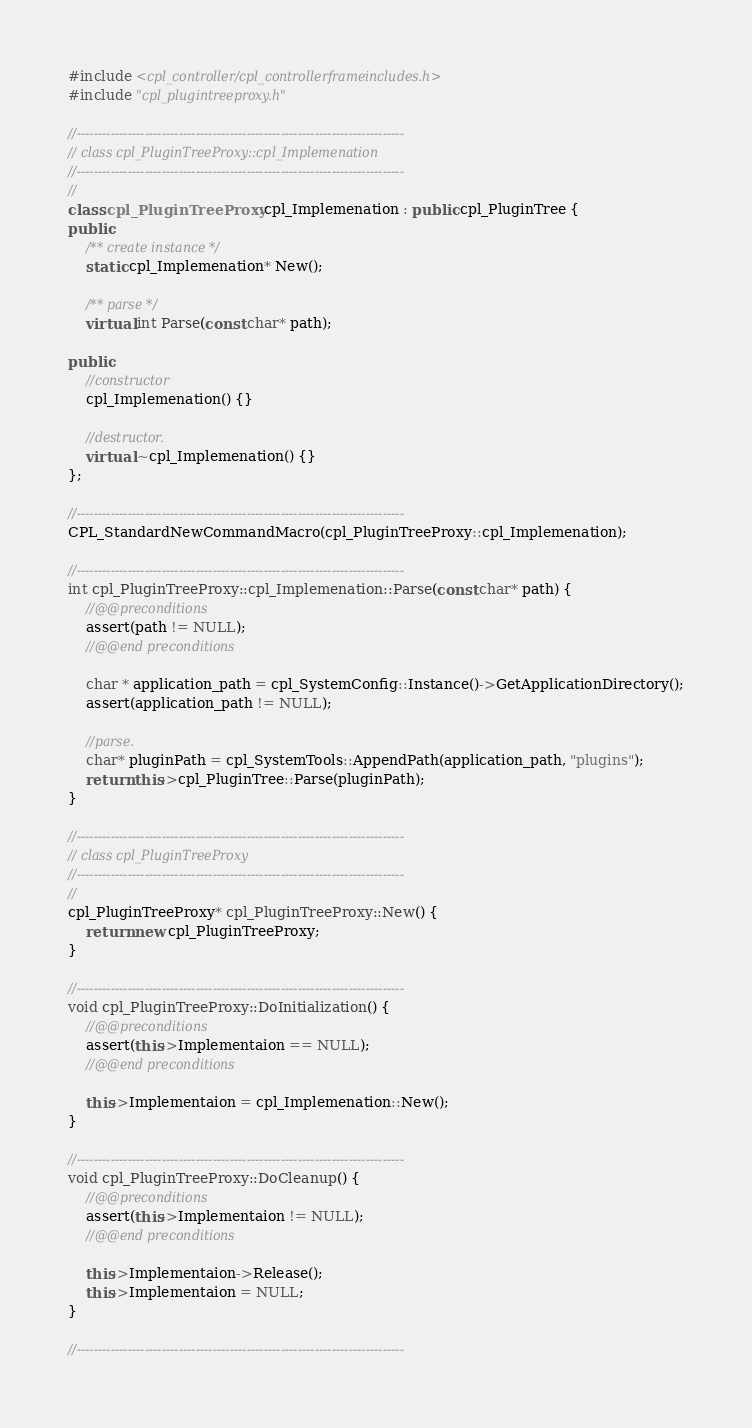<code> <loc_0><loc_0><loc_500><loc_500><_C++_>#include <cpl_controller/cpl_controllerframeincludes.h>
#include "cpl_plugintreeproxy.h"

//-----------------------------------------------------------------------------
// class cpl_PluginTreeProxy::cpl_Implemenation
//-----------------------------------------------------------------------------
//
class cpl_PluginTreeProxy::cpl_Implemenation : public cpl_PluginTree {   
public:
    /** create instance */
    static cpl_Implemenation* New();

    /** parse */
    virtual int Parse(const char* path);

public:
    //constructor
    cpl_Implemenation() {}

    //destructor.
    virtual ~cpl_Implemenation() {}
};

//-----------------------------------------------------------------------------
CPL_StandardNewCommandMacro(cpl_PluginTreeProxy::cpl_Implemenation);

//-----------------------------------------------------------------------------
int cpl_PluginTreeProxy::cpl_Implemenation::Parse(const char* path) {
    //@@preconditions
    assert(path != NULL);
    //@@end preconditions
    
    char * application_path = cpl_SystemConfig::Instance()->GetApplicationDirectory();
    assert(application_path != NULL);
    
    //parse.
    char* pluginPath = cpl_SystemTools::AppendPath(application_path, "plugins");
    return this->cpl_PluginTree::Parse(pluginPath);
}

//-----------------------------------------------------------------------------
// class cpl_PluginTreeProxy
//-----------------------------------------------------------------------------
//
cpl_PluginTreeProxy* cpl_PluginTreeProxy::New() {
    return new cpl_PluginTreeProxy;
}

//-----------------------------------------------------------------------------
void cpl_PluginTreeProxy::DoInitialization() {
    //@@preconditions
    assert(this->Implementaion == NULL);
    //@@end preconditions

    this->Implementaion = cpl_Implemenation::New();   
}

//-----------------------------------------------------------------------------
void cpl_PluginTreeProxy::DoCleanup() {
    //@@preconditions
    assert(this->Implementaion != NULL);
    //@@end preconditions

    this->Implementaion->Release();
    this->Implementaion = NULL;
}

//-----------------------------------------------------------------------------</code> 